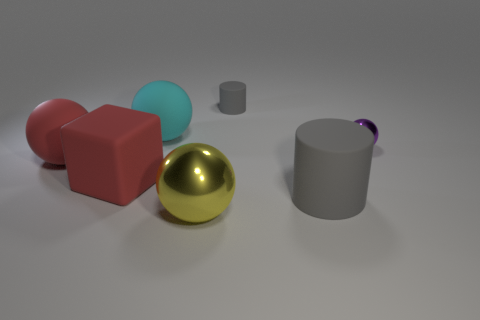There is a cylinder that is the same size as the rubber block; what is its material?
Make the answer very short. Rubber. There is a thing that is behind the sphere that is behind the thing to the right of the big gray cylinder; how big is it?
Keep it short and to the point. Small. Is the color of the thing on the left side of the matte cube the same as the metal thing left of the purple sphere?
Your answer should be compact. No. How many red things are either large matte blocks or big rubber objects?
Keep it short and to the point. 2. How many other rubber objects are the same size as the yellow object?
Your response must be concise. 4. Is the material of the large thing behind the small ball the same as the large gray object?
Offer a very short reply. Yes. Are there any large balls in front of the metal ball that is to the right of the tiny matte object?
Give a very brief answer. Yes. There is another red object that is the same shape as the small metal object; what is it made of?
Your response must be concise. Rubber. Is the number of large balls behind the small ball greater than the number of gray rubber objects that are left of the yellow sphere?
Offer a terse response. Yes. There is a big cyan thing that is the same material as the large red block; what is its shape?
Give a very brief answer. Sphere. 